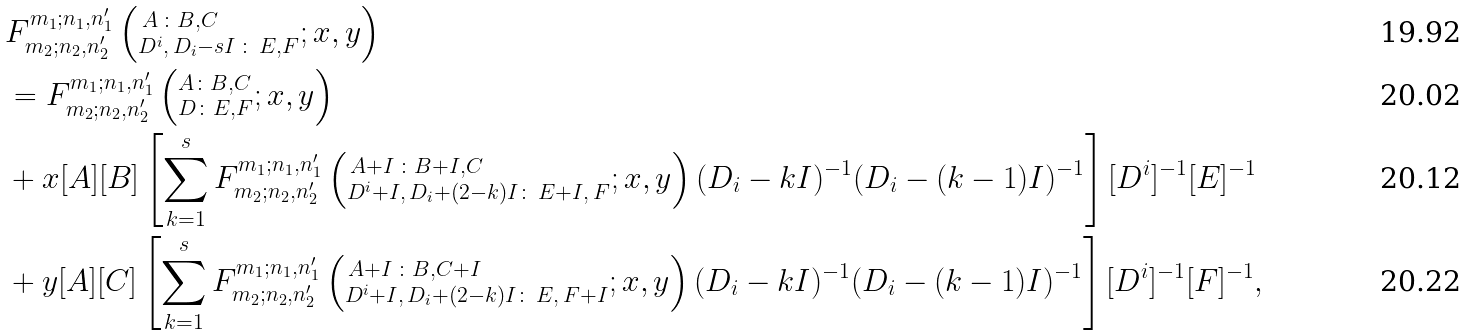<formula> <loc_0><loc_0><loc_500><loc_500>& F ^ { m _ { 1 } ; n _ { 1 } , n ^ { \prime } _ { 1 } } _ { m _ { 2 } ; n _ { 2 } , n ^ { \prime } _ { 2 } } \left ( ^ { \, A \, \colon B , C } _ { D ^ { i } , \, D _ { i } - s I \, \colon \, E , F } ; x , y \right ) \\ & = F ^ { m _ { 1 } ; n _ { 1 } , n ^ { \prime } _ { 1 } } _ { m _ { 2 } ; n _ { 2 } , n ^ { \prime } _ { 2 } } \left ( ^ { A \colon B , C } _ { D \colon E , F } ; x , y \right ) \\ & + x [ A ] [ B ] \left [ \sum _ { k = 1 } ^ { s } F ^ { m _ { 1 } ; n _ { 1 } , n ^ { \prime } _ { 1 } } _ { m _ { 2 } ; n _ { 2 } , n ^ { \prime } _ { 2 } } \left ( ^ { \, A + I \, \colon B + I , C } _ { D ^ { i } + I , \, D _ { i } + ( 2 - k ) I \colon \, E + I , \, F } ; x , y \right ) ( D _ { i } - k I ) ^ { - 1 } ( D _ { i } - ( k - 1 ) I ) ^ { - 1 } \right ] [ D ^ { i } ] ^ { - 1 } [ E ] ^ { - 1 } \\ & + y [ A ] [ C ] \left [ \sum _ { k = 1 } ^ { s } F ^ { m _ { 1 } ; n _ { 1 } , n ^ { \prime } _ { 1 } } _ { m _ { 2 } ; n _ { 2 } , n ^ { \prime } _ { 2 } } \left ( ^ { \, A + I \, \colon B , C + I } _ { D ^ { i } + I , \, D _ { i } + ( 2 - k ) I \colon \, E , \, F + I } ; x , y \right ) ( D _ { i } - k I ) ^ { - 1 } ( D _ { i } - ( k - 1 ) I ) ^ { - 1 } \right ] [ D ^ { i } ] ^ { - 1 } [ F ] ^ { - 1 } ,</formula> 